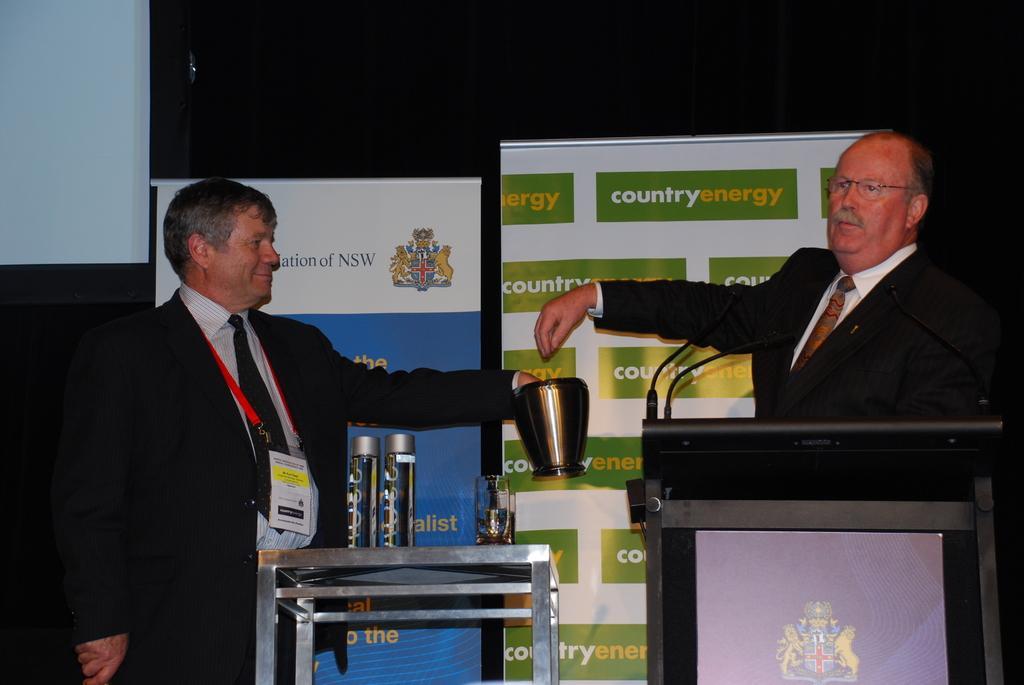Describe this image in one or two sentences. In this picture we can see two men, and they are standing, the left side person is holding a jug, in front of them we can find few microphones and bottles, in the background we can see hoardings. 